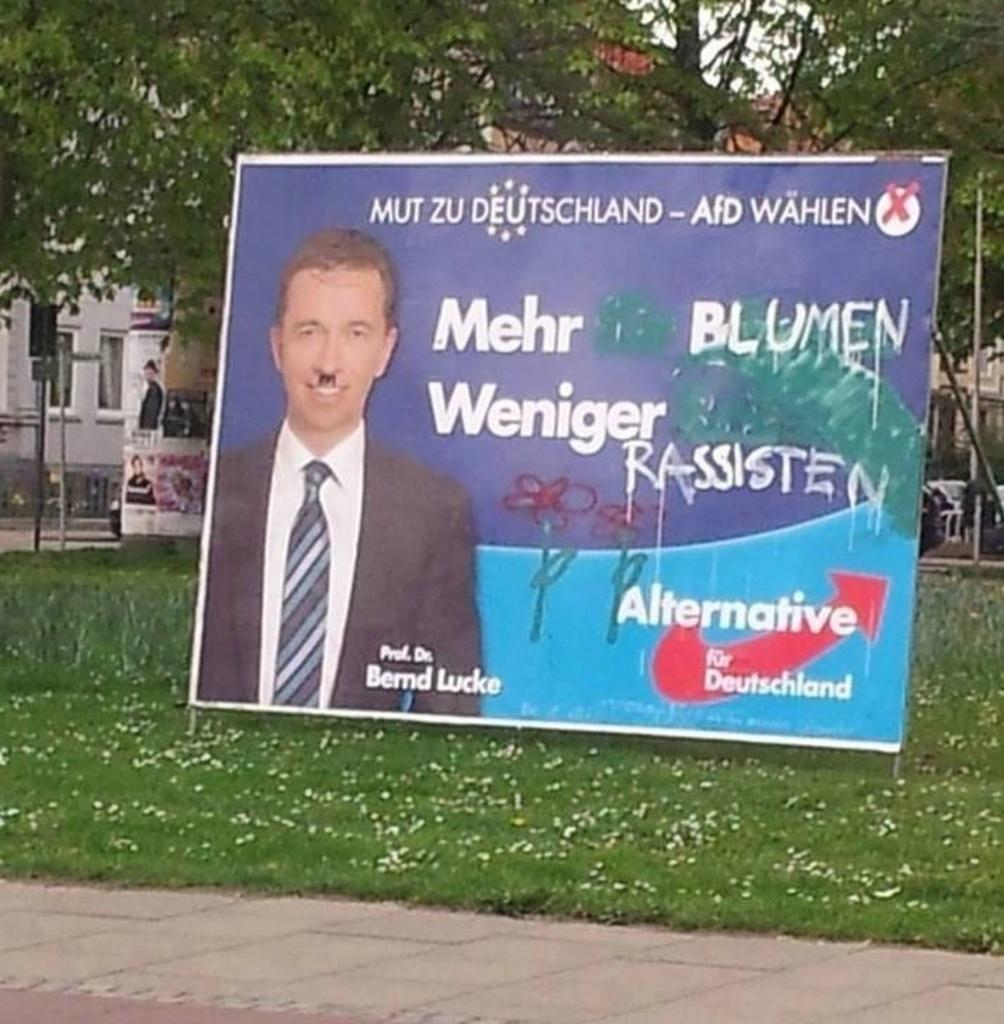What is the main object in the foreground of the image? There is a banner in the image. What is featured on the banner? A person is depicted on the banner, and there is text written on it. What can be seen in the background of the image? There is a building, trees, poles, and other objects visible in the background of the image. Can you tell me how many guns are visible in the image? There are no guns present in the image. What type of fuel can be seen being used by the person on the banner? There is no fuel or person using fuel depicted on the banner; it only features a person and text. 